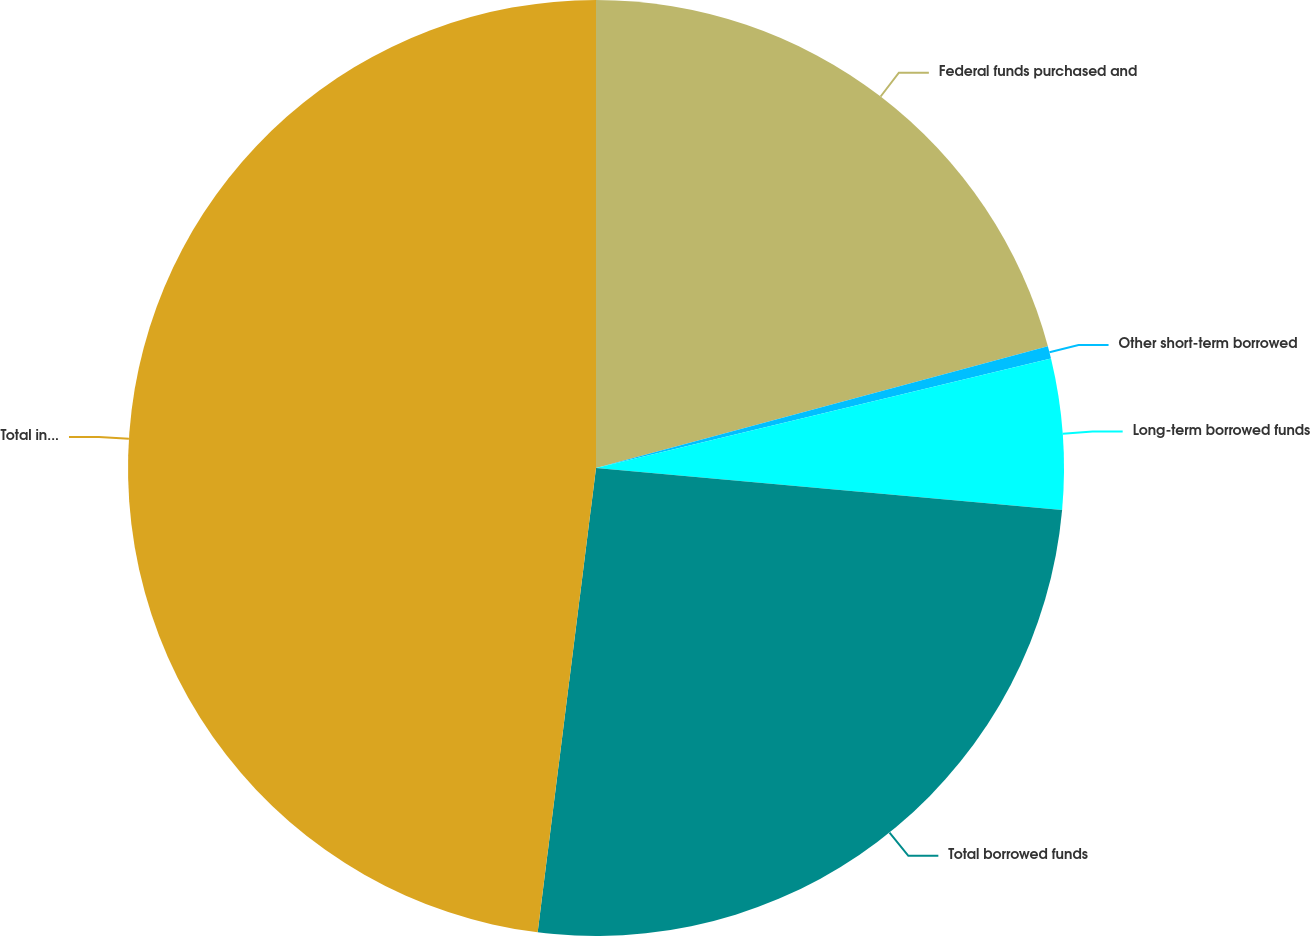Convert chart. <chart><loc_0><loc_0><loc_500><loc_500><pie_chart><fcel>Federal funds purchased and<fcel>Other short-term borrowed<fcel>Long-term borrowed funds<fcel>Total borrowed funds<fcel>Total interest-bearing<nl><fcel>20.81%<fcel>0.43%<fcel>5.19%<fcel>25.56%<fcel>48.01%<nl></chart> 